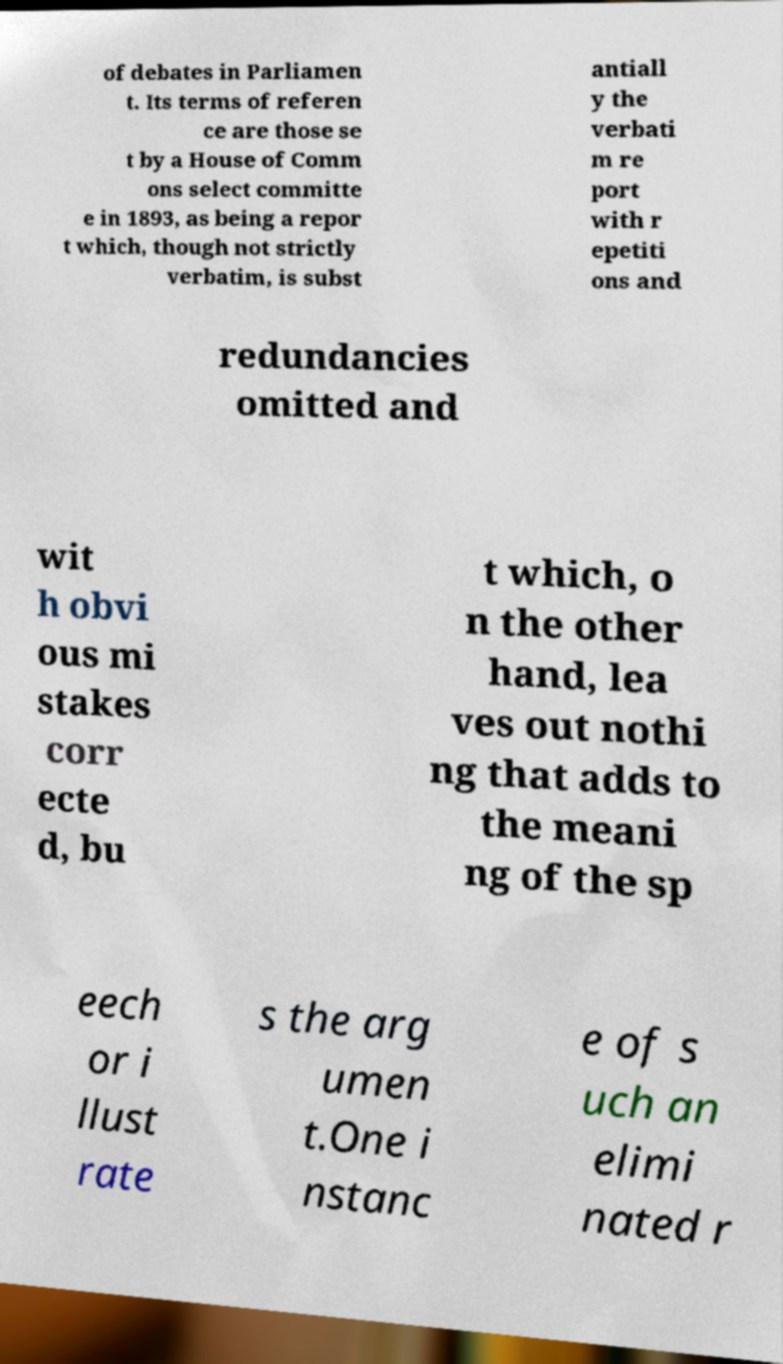I need the written content from this picture converted into text. Can you do that? of debates in Parliamen t. Its terms of referen ce are those se t by a House of Comm ons select committe e in 1893, as being a repor t which, though not strictly verbatim, is subst antiall y the verbati m re port with r epetiti ons and redundancies omitted and wit h obvi ous mi stakes corr ecte d, bu t which, o n the other hand, lea ves out nothi ng that adds to the meani ng of the sp eech or i llust rate s the arg umen t.One i nstanc e of s uch an elimi nated r 